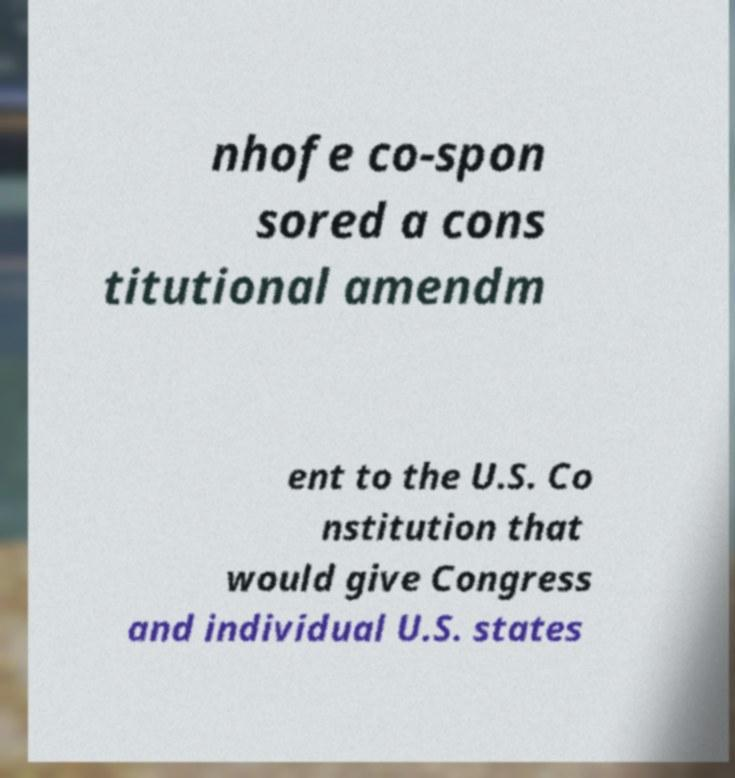Can you read and provide the text displayed in the image?This photo seems to have some interesting text. Can you extract and type it out for me? nhofe co-spon sored a cons titutional amendm ent to the U.S. Co nstitution that would give Congress and individual U.S. states 